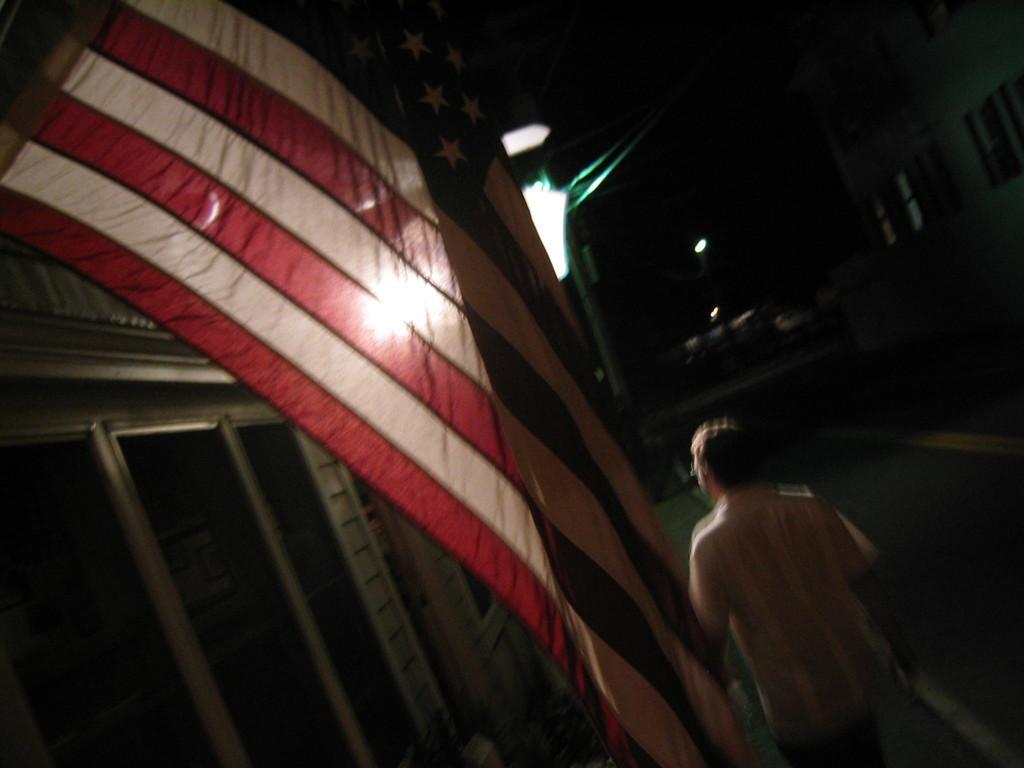Can you describe this image briefly? In this image in the front there is a flag and in the center there is a person walking. On the left side there are glasses. On the right side there is a building and there are windows. In the background there are lights and there is a pole. 